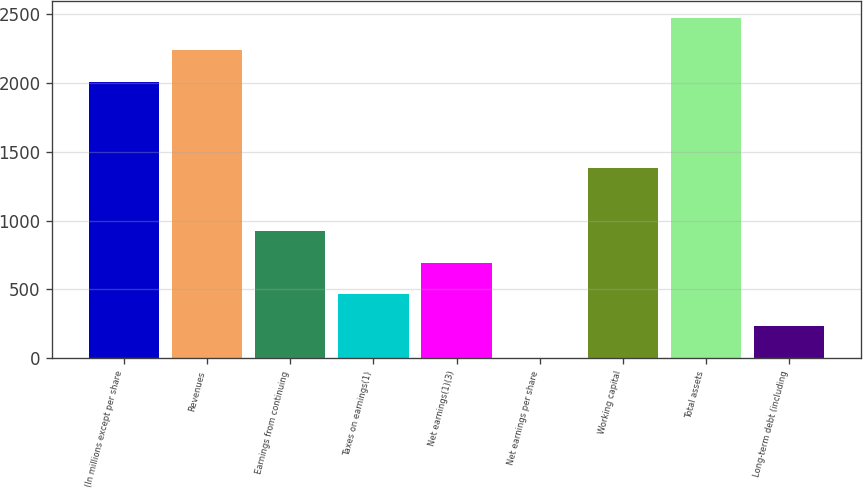Convert chart. <chart><loc_0><loc_0><loc_500><loc_500><bar_chart><fcel>(In millions except per share<fcel>Revenues<fcel>Earnings from continuing<fcel>Taxes on earnings(1)<fcel>Net earnings(1)(3)<fcel>Net earnings per share<fcel>Working capital<fcel>Total assets<fcel>Long-term debt (including<nl><fcel>2009<fcel>2239.57<fcel>924.8<fcel>463.67<fcel>694.24<fcel>2.55<fcel>1385.93<fcel>2470.14<fcel>233.11<nl></chart> 